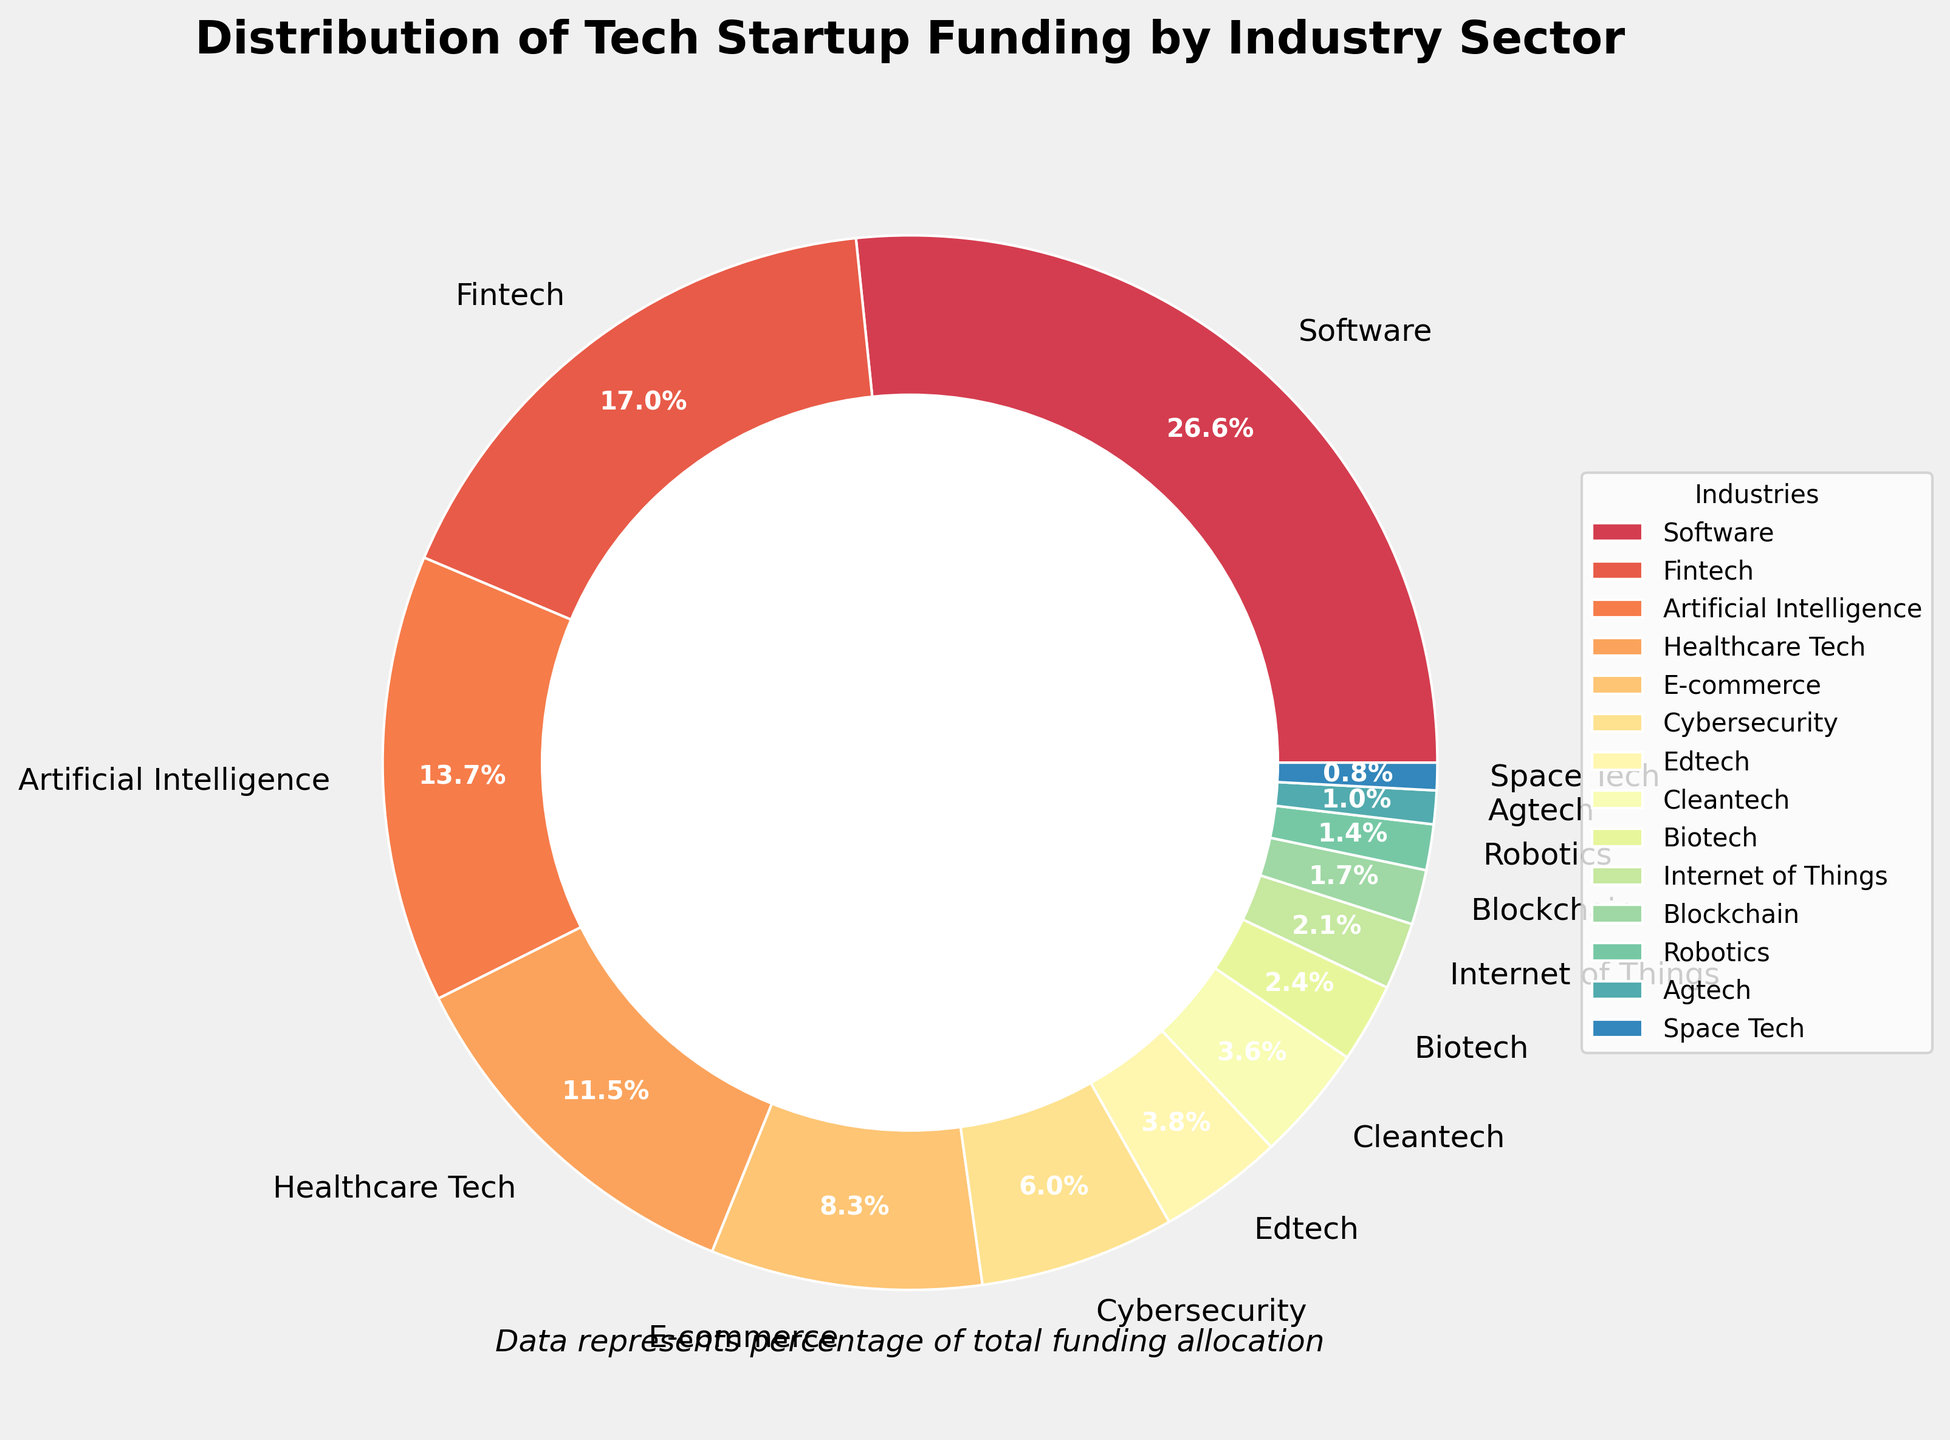What industry sector has the highest percentage of funding? The sector with the largest slice in the pie chart indicates the highest funding percentage. The software industry has the largest slice.
Answer: Software Which two sectors combined receive almost one-third of the total funding? First, identify the sectors with the high percentages, add their funding percentages: Software (28.5%) and Fintech (18.2%); their sum is 46.7%, exceeding one-third.
Answer: Software and Fintech How much more funding does the Software sector receive compared to the Healthcare Tech sector? The Software sector receives 28.5% and Healthcare Tech receives 12.3%. The difference in their funding is 28.5% - 12.3%.
Answer: 16.2% Which sector has the smallest funding percentage, and what is that percentage? Locate the area with the smallest slice in the pie chart. Agtech has the smallest slice at 0.9%.
Answer: Space Tech, 0.9% Are there more funds allocated to Cybersecurity or Blockchain? Compare the pie chart slices for Cybersecurity and Blockchain. Cybersecurity has a larger slice at 6.4%, while Blockchain has 1.8%.
Answer: Cybersecurity If the funds for E-commerce and Edtech are combined, what would their total funding percentage be? Add the funding percentages for E-commerce (8.9%) and Edtech (4.1%).
Answer: 13% What is the average funding percentage for Healthcare Tech, Edtech, and Cleantech sectors? Sum the percentages: Healthcare Tech (12.3%), Edtech (4.1%), and Cleantech (3.8%). Divide by 3: (12.3% + 4.1% + 3.8%) / 3.
Answer: 6.73% What is the difference in funding between Artificial Intelligence and the total of Biotech and Internet of Things together? Find the funding for Artificial Intelligence (14.7%), Biotech (2.6%), and Internet of Things (2.2%). Sum Biotech and IoT: 2.6% + 2.2% = 4.8%. Now, subtract: 14.7% - 4.8%.
Answer: 9.9% Do the combined funds for Space Tech, Agtech, and Robotics exceed 5% of total funding? Sum the percentages for Space Tech (0.9%), Agtech (1.1%), and Robotics (1.5%). Their total is: 0.9% + 1.1% + 1.5% = 3.5%. This does not exceed 5%.
Answer: No Which sector having more than 10% funding is closest to the percentage of Fintech? Identify sectors with over 10% funding: Software (28.5%), Healthcare Tech (12.3%). Closest to Fintech (18.2%) is Healthcare Tech at 12.3%.
Answer: Healthcare Tech 